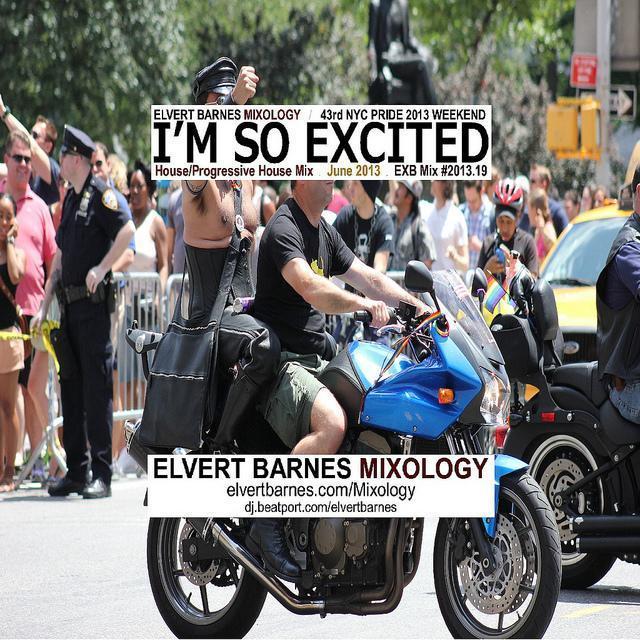How many people are there?
Give a very brief answer. 10. How many motorcycles are there?
Give a very brief answer. 2. How many traffic lights are in the photo?
Give a very brief answer. 1. 